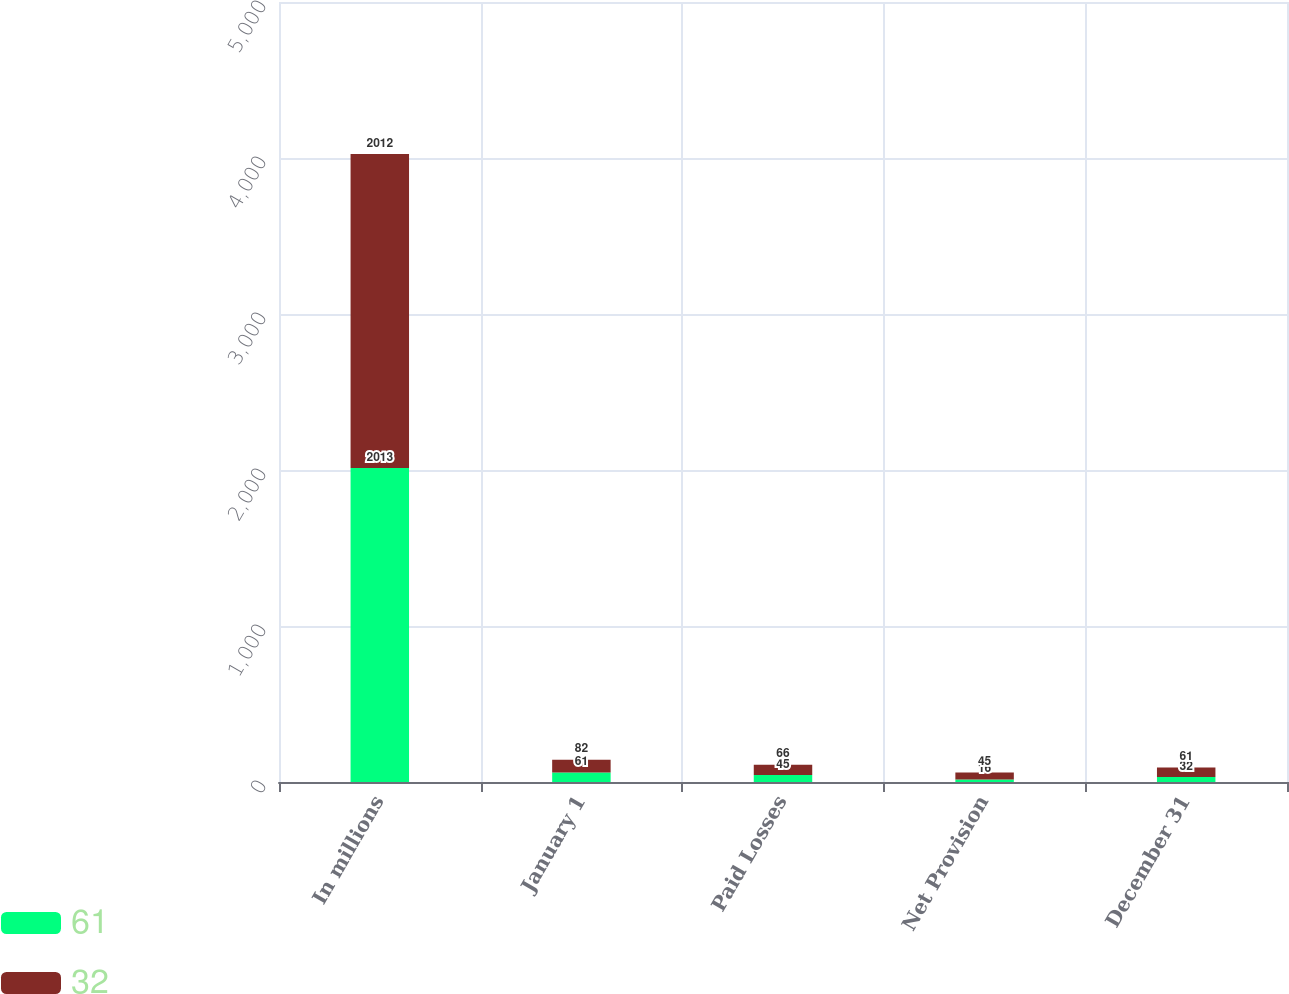Convert chart. <chart><loc_0><loc_0><loc_500><loc_500><stacked_bar_chart><ecel><fcel>In millions<fcel>January 1<fcel>Paid Losses<fcel>Net Provision<fcel>December 31<nl><fcel>61<fcel>2013<fcel>61<fcel>45<fcel>16<fcel>32<nl><fcel>32<fcel>2012<fcel>82<fcel>66<fcel>45<fcel>61<nl></chart> 